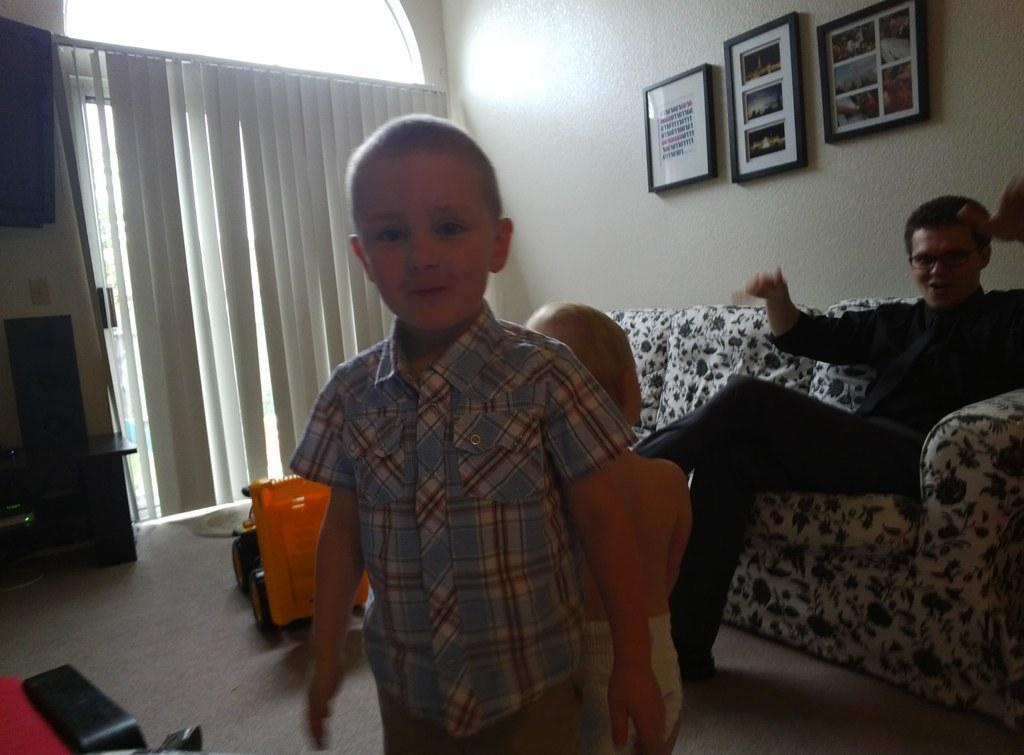Can you describe this image briefly? In the image there is a man sitting on the sofa and in front of him there are two kids standing on the floor, there is a toy vehicle behind the kids and in the background there is a wall and there are three frames attached to the wall. On the left side there is a window and there is a curtain in front of the window, beside the window there is a table and there is a television fit to the wall. 